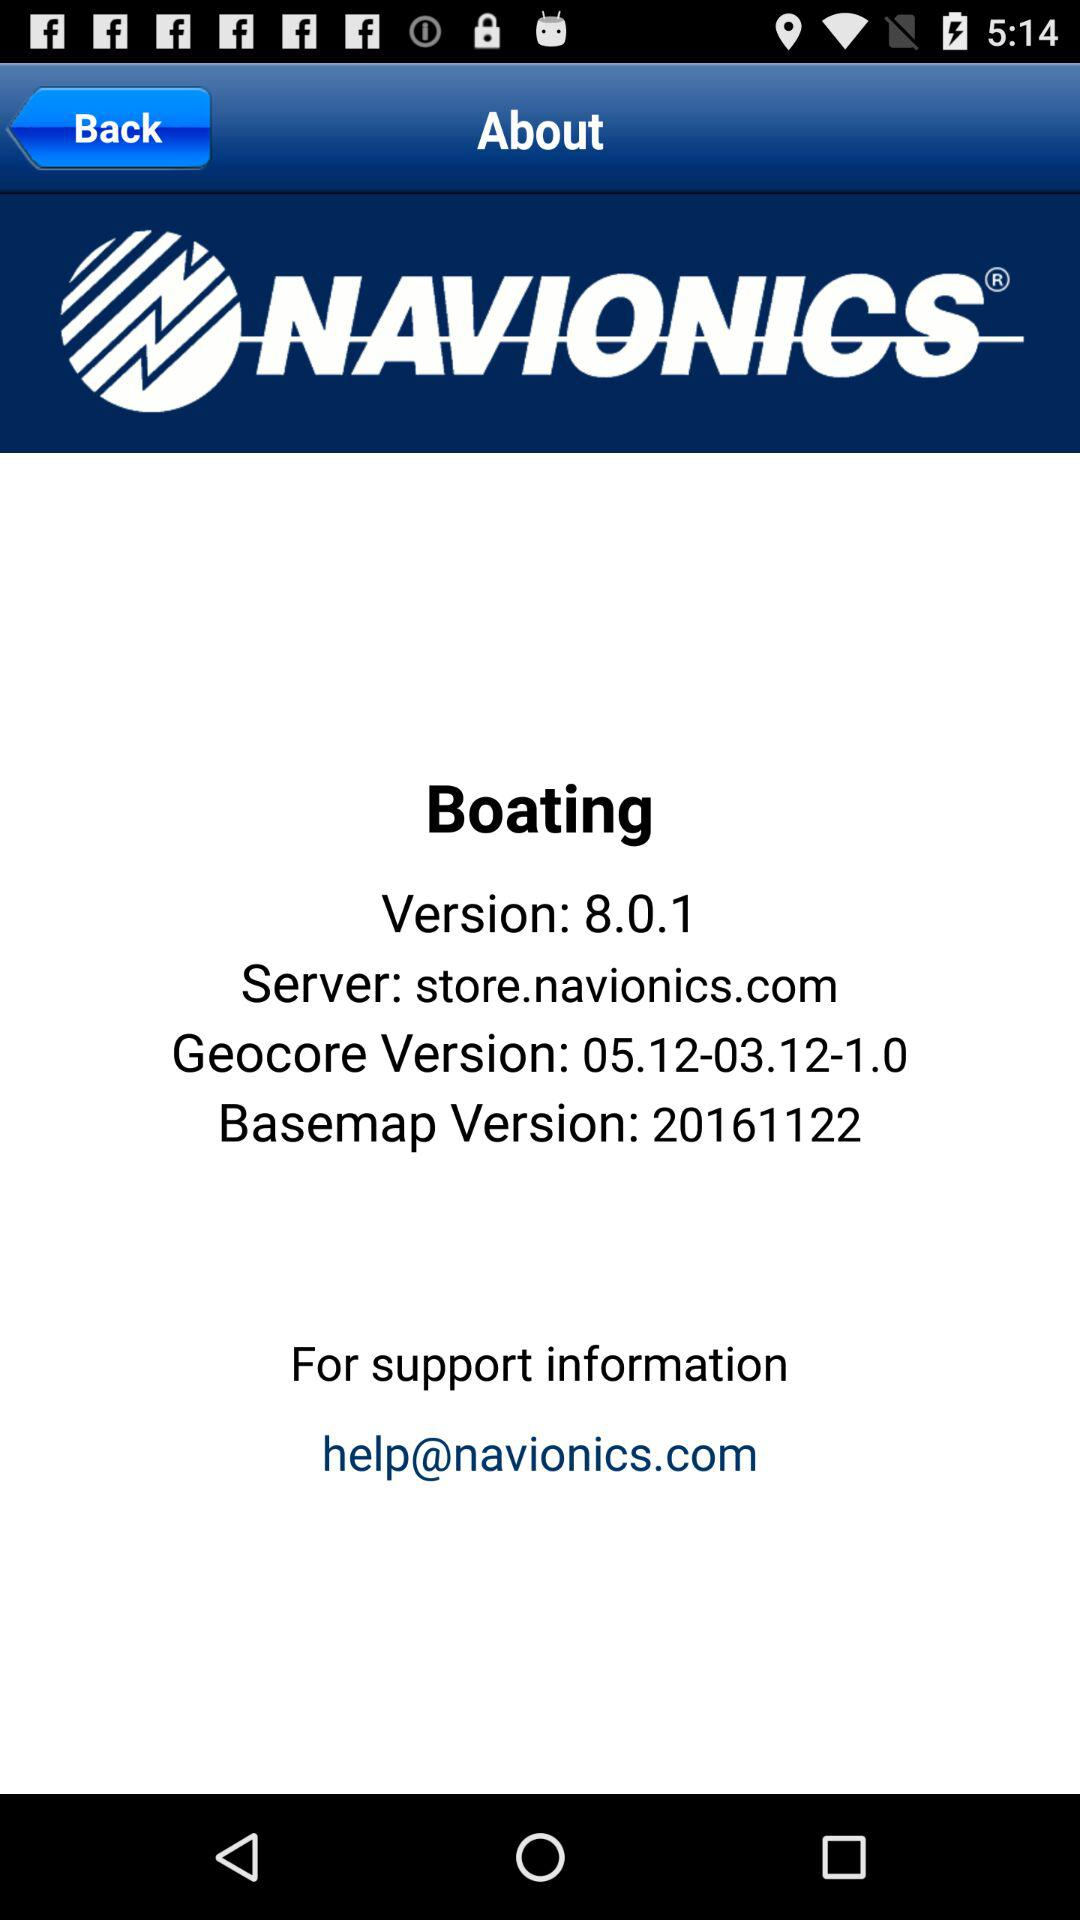What is the basemap version? The basemap version is 20161122. 